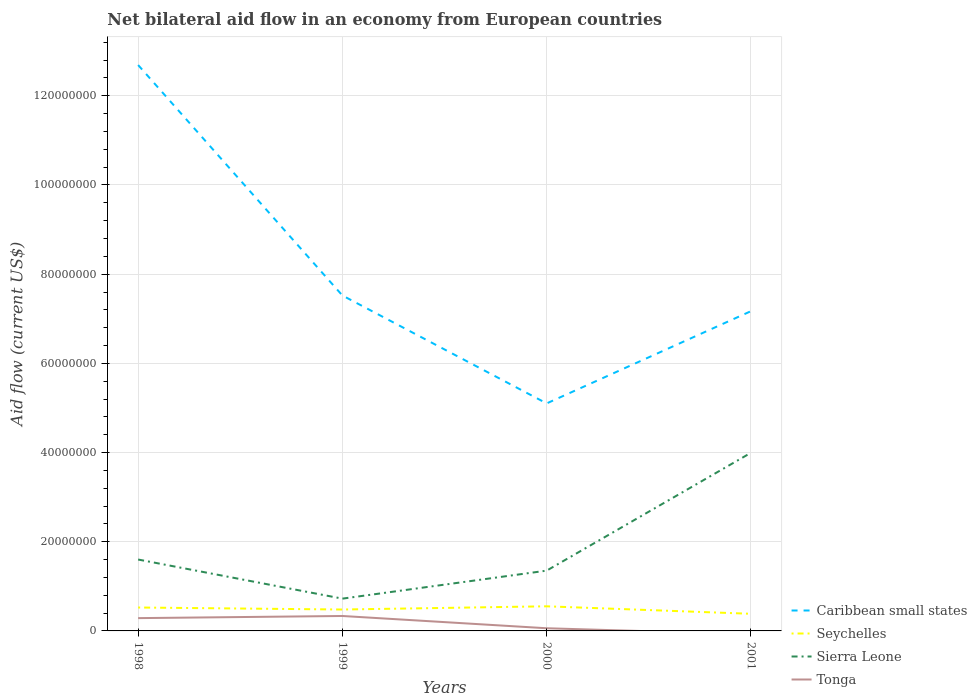Across all years, what is the maximum net bilateral aid flow in Sierra Leone?
Your response must be concise. 7.24e+06. What is the total net bilateral aid flow in Caribbean small states in the graph?
Make the answer very short. 5.52e+07. What is the difference between the highest and the second highest net bilateral aid flow in Tonga?
Your response must be concise. 3.35e+06. Is the net bilateral aid flow in Tonga strictly greater than the net bilateral aid flow in Caribbean small states over the years?
Your answer should be very brief. Yes. Does the graph contain any zero values?
Keep it short and to the point. Yes. Does the graph contain grids?
Provide a succinct answer. Yes. Where does the legend appear in the graph?
Provide a short and direct response. Bottom right. How many legend labels are there?
Ensure brevity in your answer.  4. What is the title of the graph?
Your answer should be compact. Net bilateral aid flow in an economy from European countries. Does "Pacific island small states" appear as one of the legend labels in the graph?
Provide a short and direct response. No. What is the label or title of the Y-axis?
Provide a short and direct response. Aid flow (current US$). What is the Aid flow (current US$) in Caribbean small states in 1998?
Make the answer very short. 1.27e+08. What is the Aid flow (current US$) in Seychelles in 1998?
Ensure brevity in your answer.  5.25e+06. What is the Aid flow (current US$) in Sierra Leone in 1998?
Keep it short and to the point. 1.60e+07. What is the Aid flow (current US$) of Tonga in 1998?
Your answer should be compact. 2.87e+06. What is the Aid flow (current US$) in Caribbean small states in 1999?
Make the answer very short. 7.52e+07. What is the Aid flow (current US$) of Seychelles in 1999?
Your response must be concise. 4.80e+06. What is the Aid flow (current US$) of Sierra Leone in 1999?
Offer a terse response. 7.24e+06. What is the Aid flow (current US$) of Tonga in 1999?
Your response must be concise. 3.35e+06. What is the Aid flow (current US$) in Caribbean small states in 2000?
Keep it short and to the point. 5.10e+07. What is the Aid flow (current US$) in Seychelles in 2000?
Give a very brief answer. 5.52e+06. What is the Aid flow (current US$) of Sierra Leone in 2000?
Provide a succinct answer. 1.35e+07. What is the Aid flow (current US$) of Caribbean small states in 2001?
Your response must be concise. 7.17e+07. What is the Aid flow (current US$) in Seychelles in 2001?
Provide a short and direct response. 3.84e+06. What is the Aid flow (current US$) in Sierra Leone in 2001?
Keep it short and to the point. 4.00e+07. What is the Aid flow (current US$) in Tonga in 2001?
Your response must be concise. 0. Across all years, what is the maximum Aid flow (current US$) in Caribbean small states?
Provide a succinct answer. 1.27e+08. Across all years, what is the maximum Aid flow (current US$) of Seychelles?
Keep it short and to the point. 5.52e+06. Across all years, what is the maximum Aid flow (current US$) in Sierra Leone?
Offer a terse response. 4.00e+07. Across all years, what is the maximum Aid flow (current US$) of Tonga?
Keep it short and to the point. 3.35e+06. Across all years, what is the minimum Aid flow (current US$) in Caribbean small states?
Your answer should be compact. 5.10e+07. Across all years, what is the minimum Aid flow (current US$) in Seychelles?
Offer a very short reply. 3.84e+06. Across all years, what is the minimum Aid flow (current US$) in Sierra Leone?
Make the answer very short. 7.24e+06. Across all years, what is the minimum Aid flow (current US$) in Tonga?
Ensure brevity in your answer.  0. What is the total Aid flow (current US$) of Caribbean small states in the graph?
Your response must be concise. 3.25e+08. What is the total Aid flow (current US$) of Seychelles in the graph?
Give a very brief answer. 1.94e+07. What is the total Aid flow (current US$) of Sierra Leone in the graph?
Your answer should be very brief. 7.67e+07. What is the total Aid flow (current US$) in Tonga in the graph?
Provide a short and direct response. 6.82e+06. What is the difference between the Aid flow (current US$) in Caribbean small states in 1998 and that in 1999?
Your response must be concise. 5.17e+07. What is the difference between the Aid flow (current US$) of Sierra Leone in 1998 and that in 1999?
Your answer should be compact. 8.77e+06. What is the difference between the Aid flow (current US$) of Tonga in 1998 and that in 1999?
Offer a very short reply. -4.80e+05. What is the difference between the Aid flow (current US$) of Caribbean small states in 1998 and that in 2000?
Provide a succinct answer. 7.59e+07. What is the difference between the Aid flow (current US$) in Seychelles in 1998 and that in 2000?
Offer a very short reply. -2.70e+05. What is the difference between the Aid flow (current US$) in Sierra Leone in 1998 and that in 2000?
Your answer should be very brief. 2.49e+06. What is the difference between the Aid flow (current US$) in Tonga in 1998 and that in 2000?
Your response must be concise. 2.27e+06. What is the difference between the Aid flow (current US$) of Caribbean small states in 1998 and that in 2001?
Your answer should be very brief. 5.52e+07. What is the difference between the Aid flow (current US$) in Seychelles in 1998 and that in 2001?
Your response must be concise. 1.41e+06. What is the difference between the Aid flow (current US$) of Sierra Leone in 1998 and that in 2001?
Provide a succinct answer. -2.39e+07. What is the difference between the Aid flow (current US$) of Caribbean small states in 1999 and that in 2000?
Keep it short and to the point. 2.42e+07. What is the difference between the Aid flow (current US$) in Seychelles in 1999 and that in 2000?
Give a very brief answer. -7.20e+05. What is the difference between the Aid flow (current US$) in Sierra Leone in 1999 and that in 2000?
Make the answer very short. -6.28e+06. What is the difference between the Aid flow (current US$) in Tonga in 1999 and that in 2000?
Keep it short and to the point. 2.75e+06. What is the difference between the Aid flow (current US$) in Caribbean small states in 1999 and that in 2001?
Give a very brief answer. 3.52e+06. What is the difference between the Aid flow (current US$) of Seychelles in 1999 and that in 2001?
Your answer should be compact. 9.60e+05. What is the difference between the Aid flow (current US$) in Sierra Leone in 1999 and that in 2001?
Ensure brevity in your answer.  -3.27e+07. What is the difference between the Aid flow (current US$) of Caribbean small states in 2000 and that in 2001?
Your answer should be very brief. -2.07e+07. What is the difference between the Aid flow (current US$) of Seychelles in 2000 and that in 2001?
Your answer should be compact. 1.68e+06. What is the difference between the Aid flow (current US$) in Sierra Leone in 2000 and that in 2001?
Make the answer very short. -2.64e+07. What is the difference between the Aid flow (current US$) in Caribbean small states in 1998 and the Aid flow (current US$) in Seychelles in 1999?
Your answer should be compact. 1.22e+08. What is the difference between the Aid flow (current US$) of Caribbean small states in 1998 and the Aid flow (current US$) of Sierra Leone in 1999?
Provide a short and direct response. 1.20e+08. What is the difference between the Aid flow (current US$) of Caribbean small states in 1998 and the Aid flow (current US$) of Tonga in 1999?
Your response must be concise. 1.24e+08. What is the difference between the Aid flow (current US$) of Seychelles in 1998 and the Aid flow (current US$) of Sierra Leone in 1999?
Offer a terse response. -1.99e+06. What is the difference between the Aid flow (current US$) in Seychelles in 1998 and the Aid flow (current US$) in Tonga in 1999?
Keep it short and to the point. 1.90e+06. What is the difference between the Aid flow (current US$) of Sierra Leone in 1998 and the Aid flow (current US$) of Tonga in 1999?
Provide a succinct answer. 1.27e+07. What is the difference between the Aid flow (current US$) in Caribbean small states in 1998 and the Aid flow (current US$) in Seychelles in 2000?
Make the answer very short. 1.21e+08. What is the difference between the Aid flow (current US$) in Caribbean small states in 1998 and the Aid flow (current US$) in Sierra Leone in 2000?
Your response must be concise. 1.13e+08. What is the difference between the Aid flow (current US$) of Caribbean small states in 1998 and the Aid flow (current US$) of Tonga in 2000?
Offer a very short reply. 1.26e+08. What is the difference between the Aid flow (current US$) of Seychelles in 1998 and the Aid flow (current US$) of Sierra Leone in 2000?
Make the answer very short. -8.27e+06. What is the difference between the Aid flow (current US$) of Seychelles in 1998 and the Aid flow (current US$) of Tonga in 2000?
Your response must be concise. 4.65e+06. What is the difference between the Aid flow (current US$) in Sierra Leone in 1998 and the Aid flow (current US$) in Tonga in 2000?
Your answer should be compact. 1.54e+07. What is the difference between the Aid flow (current US$) of Caribbean small states in 1998 and the Aid flow (current US$) of Seychelles in 2001?
Make the answer very short. 1.23e+08. What is the difference between the Aid flow (current US$) of Caribbean small states in 1998 and the Aid flow (current US$) of Sierra Leone in 2001?
Your response must be concise. 8.70e+07. What is the difference between the Aid flow (current US$) in Seychelles in 1998 and the Aid flow (current US$) in Sierra Leone in 2001?
Keep it short and to the point. -3.47e+07. What is the difference between the Aid flow (current US$) of Caribbean small states in 1999 and the Aid flow (current US$) of Seychelles in 2000?
Your answer should be compact. 6.97e+07. What is the difference between the Aid flow (current US$) of Caribbean small states in 1999 and the Aid flow (current US$) of Sierra Leone in 2000?
Provide a succinct answer. 6.17e+07. What is the difference between the Aid flow (current US$) of Caribbean small states in 1999 and the Aid flow (current US$) of Tonga in 2000?
Provide a succinct answer. 7.46e+07. What is the difference between the Aid flow (current US$) of Seychelles in 1999 and the Aid flow (current US$) of Sierra Leone in 2000?
Ensure brevity in your answer.  -8.72e+06. What is the difference between the Aid flow (current US$) of Seychelles in 1999 and the Aid flow (current US$) of Tonga in 2000?
Ensure brevity in your answer.  4.20e+06. What is the difference between the Aid flow (current US$) of Sierra Leone in 1999 and the Aid flow (current US$) of Tonga in 2000?
Provide a short and direct response. 6.64e+06. What is the difference between the Aid flow (current US$) in Caribbean small states in 1999 and the Aid flow (current US$) in Seychelles in 2001?
Keep it short and to the point. 7.14e+07. What is the difference between the Aid flow (current US$) in Caribbean small states in 1999 and the Aid flow (current US$) in Sierra Leone in 2001?
Provide a short and direct response. 3.53e+07. What is the difference between the Aid flow (current US$) in Seychelles in 1999 and the Aid flow (current US$) in Sierra Leone in 2001?
Ensure brevity in your answer.  -3.52e+07. What is the difference between the Aid flow (current US$) in Caribbean small states in 2000 and the Aid flow (current US$) in Seychelles in 2001?
Offer a terse response. 4.72e+07. What is the difference between the Aid flow (current US$) of Caribbean small states in 2000 and the Aid flow (current US$) of Sierra Leone in 2001?
Provide a short and direct response. 1.11e+07. What is the difference between the Aid flow (current US$) in Seychelles in 2000 and the Aid flow (current US$) in Sierra Leone in 2001?
Keep it short and to the point. -3.44e+07. What is the average Aid flow (current US$) in Caribbean small states per year?
Offer a terse response. 8.12e+07. What is the average Aid flow (current US$) in Seychelles per year?
Give a very brief answer. 4.85e+06. What is the average Aid flow (current US$) in Sierra Leone per year?
Make the answer very short. 1.92e+07. What is the average Aid flow (current US$) of Tonga per year?
Your answer should be very brief. 1.70e+06. In the year 1998, what is the difference between the Aid flow (current US$) of Caribbean small states and Aid flow (current US$) of Seychelles?
Offer a terse response. 1.22e+08. In the year 1998, what is the difference between the Aid flow (current US$) of Caribbean small states and Aid flow (current US$) of Sierra Leone?
Provide a short and direct response. 1.11e+08. In the year 1998, what is the difference between the Aid flow (current US$) of Caribbean small states and Aid flow (current US$) of Tonga?
Make the answer very short. 1.24e+08. In the year 1998, what is the difference between the Aid flow (current US$) of Seychelles and Aid flow (current US$) of Sierra Leone?
Make the answer very short. -1.08e+07. In the year 1998, what is the difference between the Aid flow (current US$) of Seychelles and Aid flow (current US$) of Tonga?
Provide a succinct answer. 2.38e+06. In the year 1998, what is the difference between the Aid flow (current US$) in Sierra Leone and Aid flow (current US$) in Tonga?
Provide a short and direct response. 1.31e+07. In the year 1999, what is the difference between the Aid flow (current US$) in Caribbean small states and Aid flow (current US$) in Seychelles?
Offer a terse response. 7.04e+07. In the year 1999, what is the difference between the Aid flow (current US$) in Caribbean small states and Aid flow (current US$) in Sierra Leone?
Provide a short and direct response. 6.80e+07. In the year 1999, what is the difference between the Aid flow (current US$) of Caribbean small states and Aid flow (current US$) of Tonga?
Your answer should be compact. 7.19e+07. In the year 1999, what is the difference between the Aid flow (current US$) of Seychelles and Aid flow (current US$) of Sierra Leone?
Keep it short and to the point. -2.44e+06. In the year 1999, what is the difference between the Aid flow (current US$) of Seychelles and Aid flow (current US$) of Tonga?
Keep it short and to the point. 1.45e+06. In the year 1999, what is the difference between the Aid flow (current US$) of Sierra Leone and Aid flow (current US$) of Tonga?
Ensure brevity in your answer.  3.89e+06. In the year 2000, what is the difference between the Aid flow (current US$) in Caribbean small states and Aid flow (current US$) in Seychelles?
Your answer should be very brief. 4.55e+07. In the year 2000, what is the difference between the Aid flow (current US$) of Caribbean small states and Aid flow (current US$) of Sierra Leone?
Keep it short and to the point. 3.75e+07. In the year 2000, what is the difference between the Aid flow (current US$) in Caribbean small states and Aid flow (current US$) in Tonga?
Your response must be concise. 5.04e+07. In the year 2000, what is the difference between the Aid flow (current US$) in Seychelles and Aid flow (current US$) in Sierra Leone?
Keep it short and to the point. -8.00e+06. In the year 2000, what is the difference between the Aid flow (current US$) of Seychelles and Aid flow (current US$) of Tonga?
Your answer should be compact. 4.92e+06. In the year 2000, what is the difference between the Aid flow (current US$) of Sierra Leone and Aid flow (current US$) of Tonga?
Your response must be concise. 1.29e+07. In the year 2001, what is the difference between the Aid flow (current US$) of Caribbean small states and Aid flow (current US$) of Seychelles?
Keep it short and to the point. 6.79e+07. In the year 2001, what is the difference between the Aid flow (current US$) of Caribbean small states and Aid flow (current US$) of Sierra Leone?
Give a very brief answer. 3.18e+07. In the year 2001, what is the difference between the Aid flow (current US$) in Seychelles and Aid flow (current US$) in Sierra Leone?
Ensure brevity in your answer.  -3.61e+07. What is the ratio of the Aid flow (current US$) of Caribbean small states in 1998 to that in 1999?
Offer a very short reply. 1.69. What is the ratio of the Aid flow (current US$) of Seychelles in 1998 to that in 1999?
Offer a very short reply. 1.09. What is the ratio of the Aid flow (current US$) in Sierra Leone in 1998 to that in 1999?
Your answer should be compact. 2.21. What is the ratio of the Aid flow (current US$) of Tonga in 1998 to that in 1999?
Your response must be concise. 0.86. What is the ratio of the Aid flow (current US$) of Caribbean small states in 1998 to that in 2000?
Your answer should be compact. 2.49. What is the ratio of the Aid flow (current US$) of Seychelles in 1998 to that in 2000?
Your response must be concise. 0.95. What is the ratio of the Aid flow (current US$) in Sierra Leone in 1998 to that in 2000?
Provide a short and direct response. 1.18. What is the ratio of the Aid flow (current US$) in Tonga in 1998 to that in 2000?
Your answer should be very brief. 4.78. What is the ratio of the Aid flow (current US$) of Caribbean small states in 1998 to that in 2001?
Offer a terse response. 1.77. What is the ratio of the Aid flow (current US$) of Seychelles in 1998 to that in 2001?
Your response must be concise. 1.37. What is the ratio of the Aid flow (current US$) of Sierra Leone in 1998 to that in 2001?
Keep it short and to the point. 0.4. What is the ratio of the Aid flow (current US$) of Caribbean small states in 1999 to that in 2000?
Provide a short and direct response. 1.47. What is the ratio of the Aid flow (current US$) of Seychelles in 1999 to that in 2000?
Provide a short and direct response. 0.87. What is the ratio of the Aid flow (current US$) in Sierra Leone in 1999 to that in 2000?
Your answer should be very brief. 0.54. What is the ratio of the Aid flow (current US$) in Tonga in 1999 to that in 2000?
Make the answer very short. 5.58. What is the ratio of the Aid flow (current US$) in Caribbean small states in 1999 to that in 2001?
Provide a succinct answer. 1.05. What is the ratio of the Aid flow (current US$) of Seychelles in 1999 to that in 2001?
Your answer should be compact. 1.25. What is the ratio of the Aid flow (current US$) of Sierra Leone in 1999 to that in 2001?
Your answer should be very brief. 0.18. What is the ratio of the Aid flow (current US$) of Caribbean small states in 2000 to that in 2001?
Provide a succinct answer. 0.71. What is the ratio of the Aid flow (current US$) of Seychelles in 2000 to that in 2001?
Offer a terse response. 1.44. What is the ratio of the Aid flow (current US$) of Sierra Leone in 2000 to that in 2001?
Your response must be concise. 0.34. What is the difference between the highest and the second highest Aid flow (current US$) in Caribbean small states?
Your answer should be very brief. 5.17e+07. What is the difference between the highest and the second highest Aid flow (current US$) of Sierra Leone?
Your answer should be very brief. 2.39e+07. What is the difference between the highest and the lowest Aid flow (current US$) in Caribbean small states?
Ensure brevity in your answer.  7.59e+07. What is the difference between the highest and the lowest Aid flow (current US$) in Seychelles?
Offer a terse response. 1.68e+06. What is the difference between the highest and the lowest Aid flow (current US$) in Sierra Leone?
Make the answer very short. 3.27e+07. What is the difference between the highest and the lowest Aid flow (current US$) of Tonga?
Ensure brevity in your answer.  3.35e+06. 